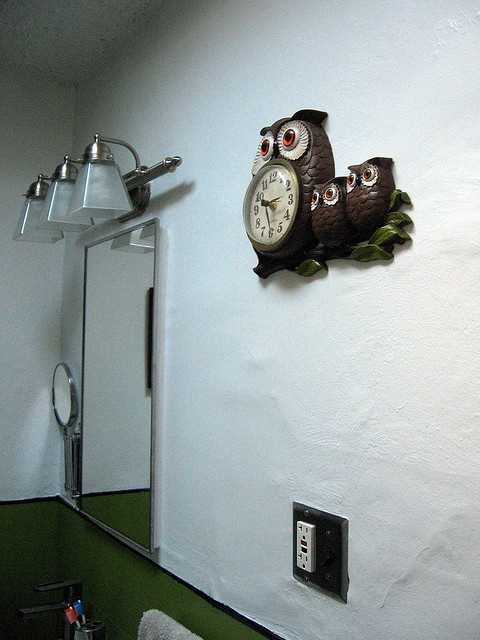Describe the objects in this image and their specific colors. I can see clock in black, darkgray, gray, beige, and darkgreen tones, bird in black, maroon, gray, and white tones, toothbrush in black, navy, gray, and blue tones, and toothbrush in black, brown, gray, and maroon tones in this image. 